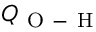<formula> <loc_0><loc_0><loc_500><loc_500>Q _ { O - H }</formula> 